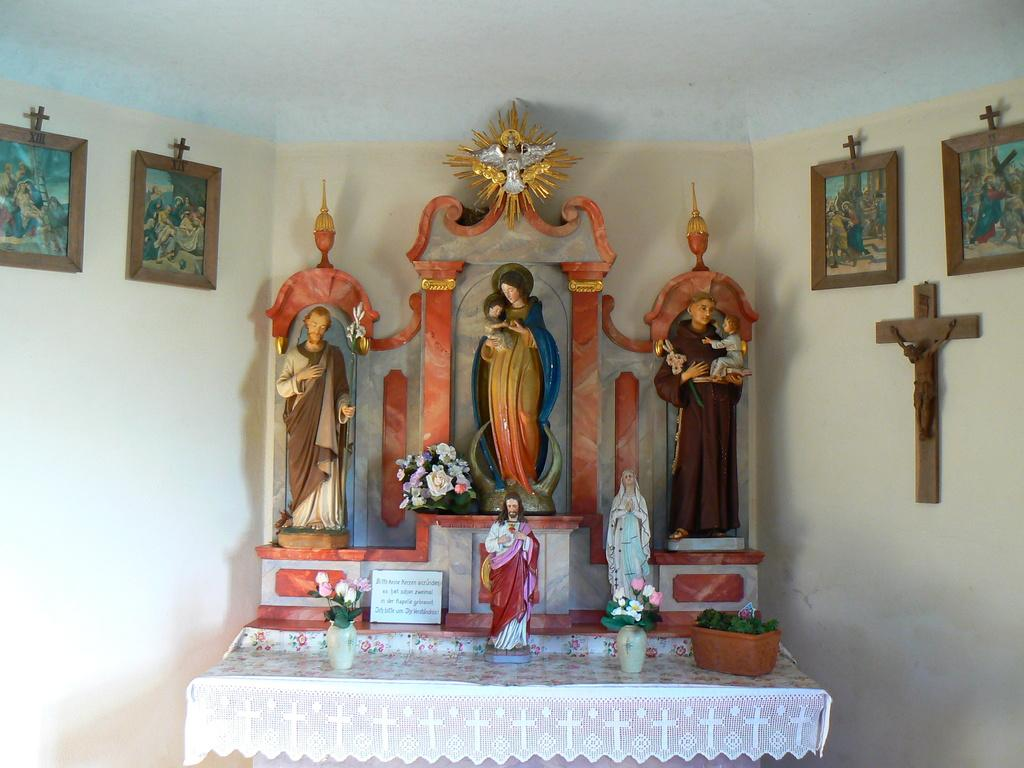What type of figures can be seen in the image? There are statues of gods in the image. What architectural elements are present in the image? There are walls in the image. What can be found on the walls in the image? There are photos on the walls in the image. What type of pigs can be seen in the image? There are no pigs present in the image. What smell can be detected in the image? The image is a visual representation, so there is no smell to detect. 